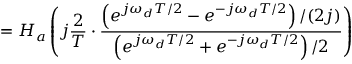Convert formula to latex. <formula><loc_0><loc_0><loc_500><loc_500>= H _ { a } \left ( j { \frac { 2 } { T } } \cdot { \frac { \left ( e ^ { j \omega _ { d } T / 2 } - e ^ { - j \omega _ { d } T / 2 } \right ) / ( 2 j ) } { \left ( e ^ { j \omega _ { d } T / 2 } + e ^ { - j \omega _ { d } T / 2 } \right ) / 2 } } \right )</formula> 